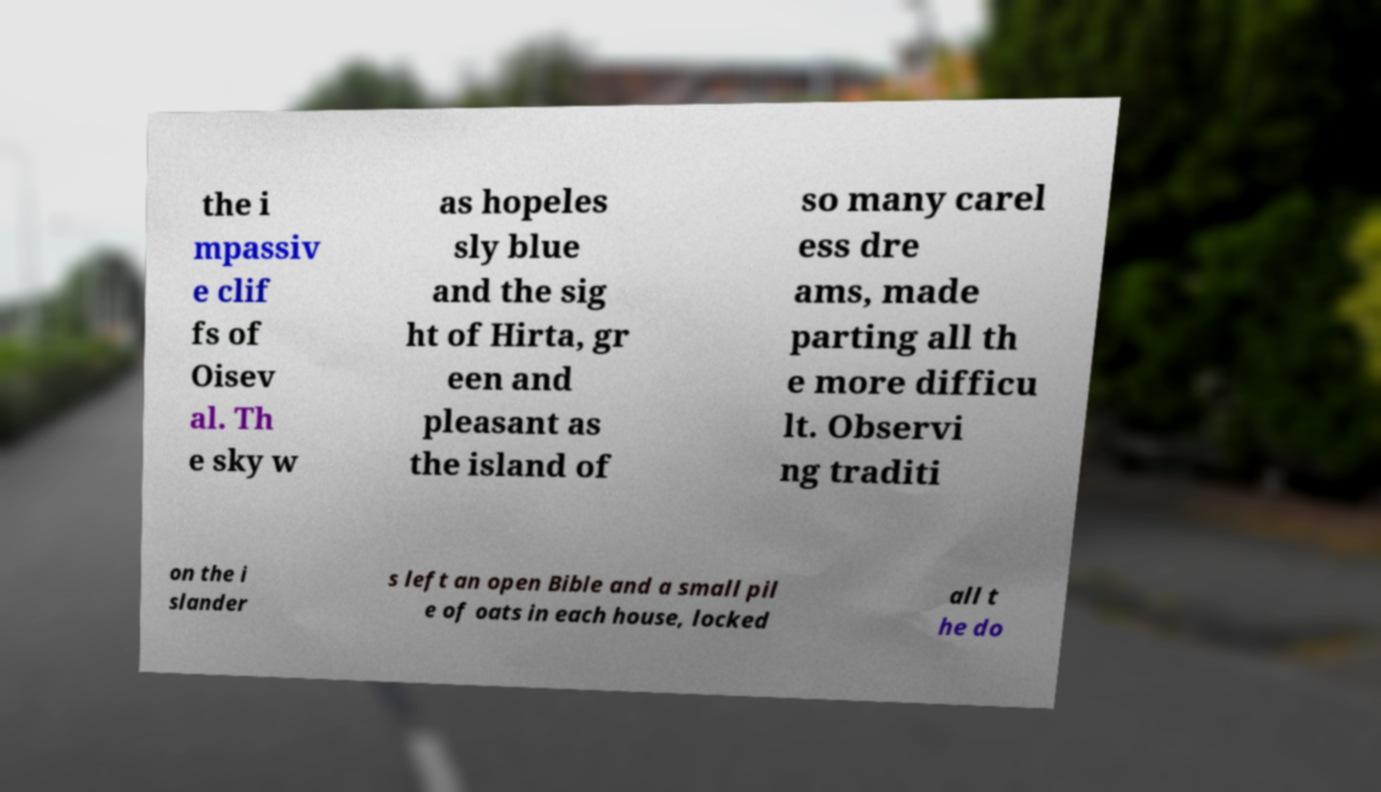There's text embedded in this image that I need extracted. Can you transcribe it verbatim? the i mpassiv e clif fs of Oisev al. Th e sky w as hopeles sly blue and the sig ht of Hirta, gr een and pleasant as the island of so many carel ess dre ams, made parting all th e more difficu lt. Observi ng traditi on the i slander s left an open Bible and a small pil e of oats in each house, locked all t he do 